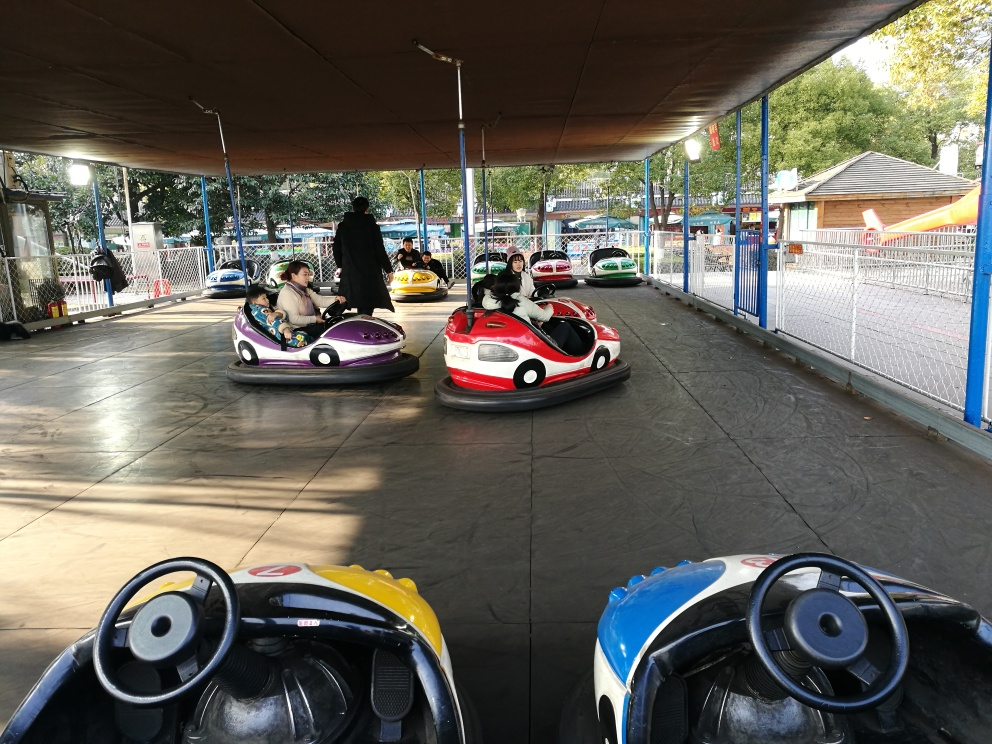Is the tone of this image harsh? The tone of the image is not harsh; rather, it has a playful and leisurely atmosphere, as it appears to capture people enjoying a ride on bumper cars in an amusement park setting. The lighting is gentle and the setting seems to be safe and family-friendly. 